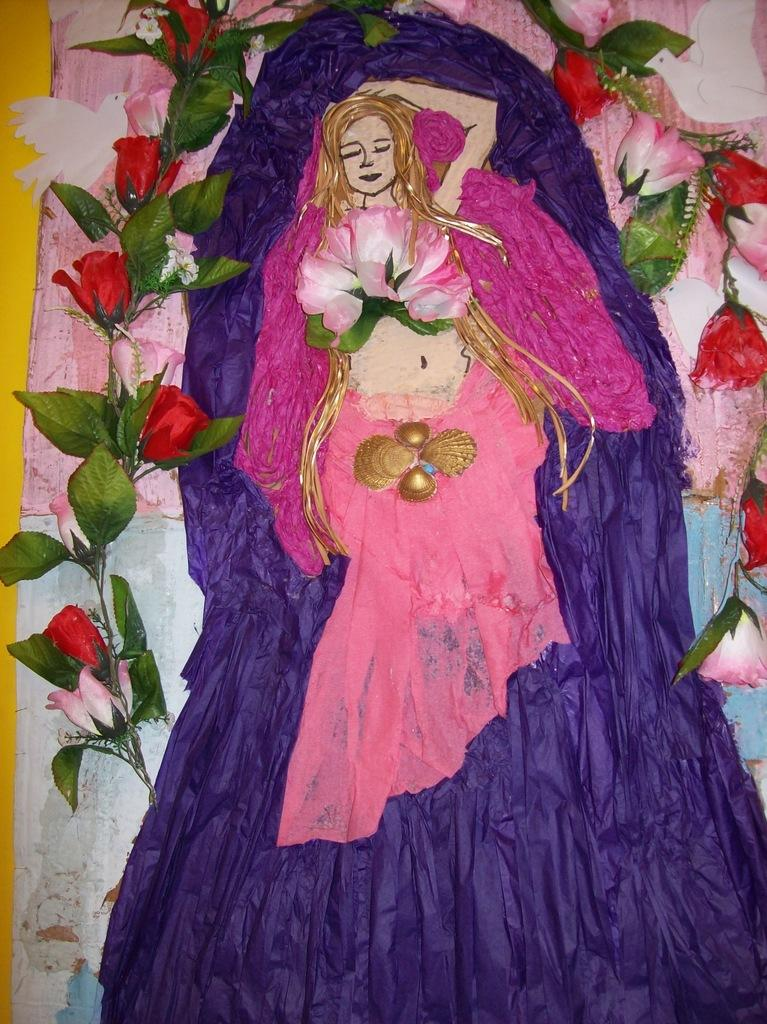How many goldfish can be seen swimming in the quicksand at the party in the image? There is no image provided, and therefore no goldfish, quicksand, or party can be observed. 